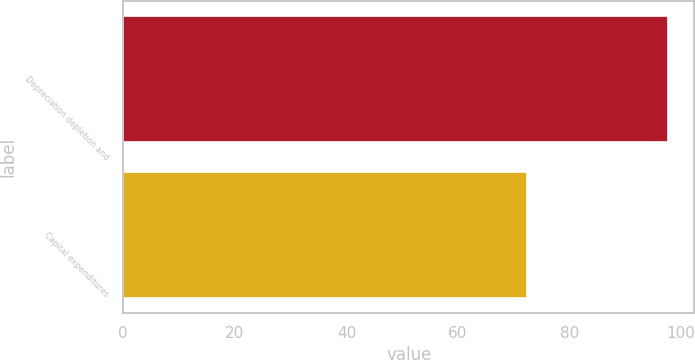<chart> <loc_0><loc_0><loc_500><loc_500><bar_chart><fcel>Depreciation depletion and<fcel>Capital expenditures<nl><fcel>97.5<fcel>72.2<nl></chart> 